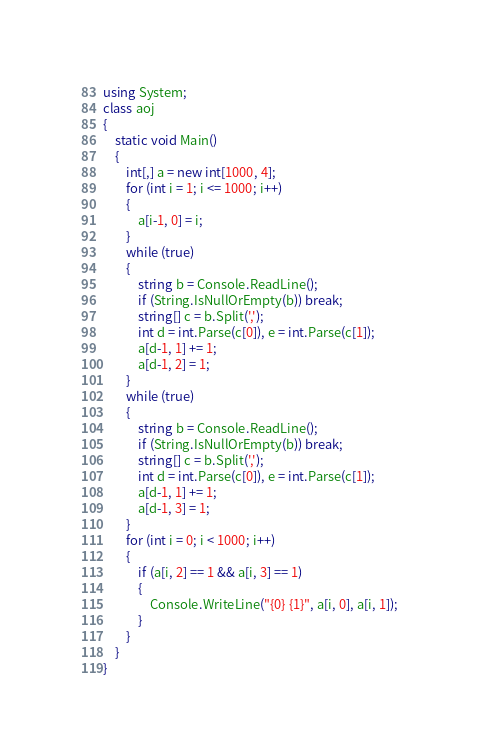Convert code to text. <code><loc_0><loc_0><loc_500><loc_500><_C#_>using System;
class aoj
{
    static void Main()
    {
        int[,] a = new int[1000, 4];
        for (int i = 1; i <= 1000; i++)
        {
            a[i-1, 0] = i;
        }
        while (true)
        {
            string b = Console.ReadLine();
            if (String.IsNullOrEmpty(b)) break;
            string[] c = b.Split(',');
            int d = int.Parse(c[0]), e = int.Parse(c[1]);
            a[d-1, 1] += 1;
            a[d-1, 2] = 1;
        }
        while (true)
        {
            string b = Console.ReadLine();
            if (String.IsNullOrEmpty(b)) break;
            string[] c = b.Split(',');
            int d = int.Parse(c[0]), e = int.Parse(c[1]);
            a[d-1, 1] += 1;
            a[d-1, 3] = 1;
        }
        for (int i = 0; i < 1000; i++)
        {
            if (a[i, 2] == 1 && a[i, 3] == 1)
            {
                Console.WriteLine("{0} {1}", a[i, 0], a[i, 1]);
            }
        }
    }
}</code> 